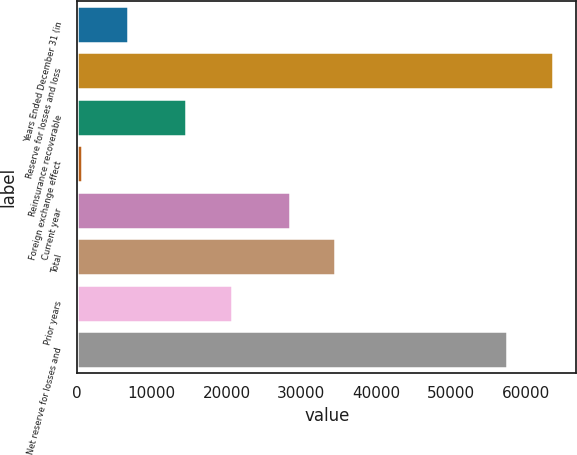Convert chart to OTSL. <chart><loc_0><loc_0><loc_500><loc_500><bar_chart><fcel>Years Ended December 31 (in<fcel>Reserve for losses and loss<fcel>Reinsurance recoverable<fcel>Foreign exchange effect<fcel>Current year<fcel>Total<fcel>Prior years<fcel>Net reserve for losses and<nl><fcel>6753<fcel>63601<fcel>14624<fcel>628<fcel>28426<fcel>34551<fcel>20749<fcel>57476<nl></chart> 